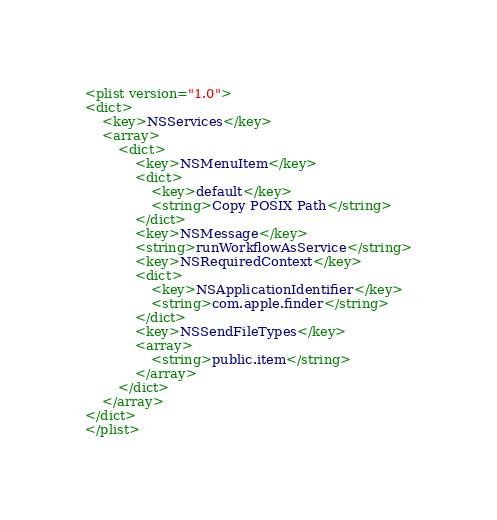<code> <loc_0><loc_0><loc_500><loc_500><_XML_><plist version="1.0">
<dict>
	<key>NSServices</key>
	<array>
		<dict>
			<key>NSMenuItem</key>
			<dict>
				<key>default</key>
				<string>Copy POSIX Path</string>
			</dict>
			<key>NSMessage</key>
			<string>runWorkflowAsService</string>
			<key>NSRequiredContext</key>
			<dict>
				<key>NSApplicationIdentifier</key>
				<string>com.apple.finder</string>
			</dict>
			<key>NSSendFileTypes</key>
			<array>
				<string>public.item</string>
			</array>
		</dict>
	</array>
</dict>
</plist>
</code> 